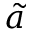<formula> <loc_0><loc_0><loc_500><loc_500>\tilde { a }</formula> 